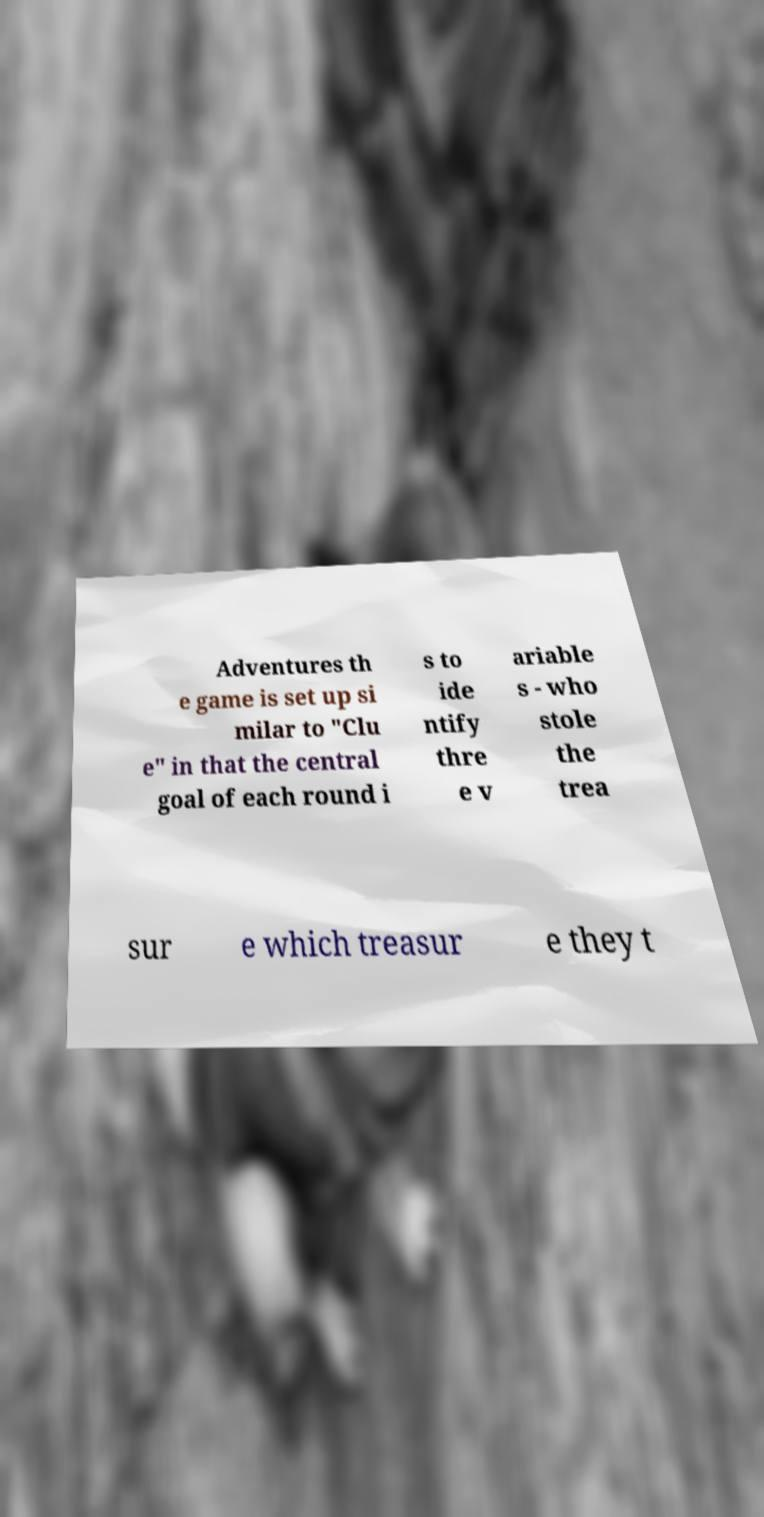Could you assist in decoding the text presented in this image and type it out clearly? Adventures th e game is set up si milar to "Clu e" in that the central goal of each round i s to ide ntify thre e v ariable s - who stole the trea sur e which treasur e they t 